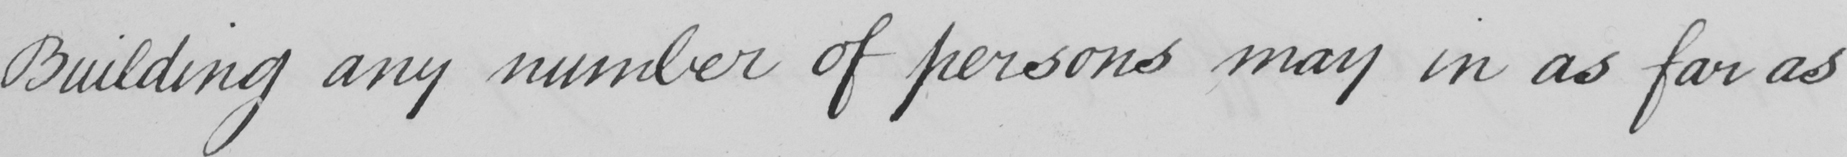Can you read and transcribe this handwriting? Building any number of persons may in as far as 